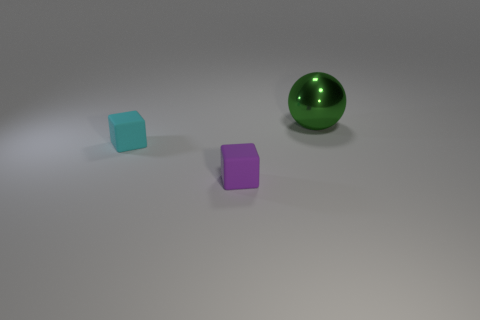How many shiny things have the same color as the metallic sphere?
Offer a terse response. 0. There is a purple rubber thing that is the same size as the cyan thing; what is its shape?
Keep it short and to the point. Cube. Is there a green object that has the same size as the metal sphere?
Offer a terse response. No. What is the material of the cyan cube that is the same size as the purple rubber object?
Your response must be concise. Rubber. What size is the rubber block right of the matte cube behind the purple rubber block?
Your answer should be very brief. Small. Do the rubber thing that is right of the cyan cube and the green sphere have the same size?
Provide a succinct answer. No. Is the number of green balls to the left of the green sphere greater than the number of cyan blocks behind the tiny cyan matte object?
Your answer should be very brief. No. The thing that is both in front of the big green metal sphere and behind the tiny purple object has what shape?
Offer a very short reply. Cube. What shape is the tiny matte thing that is right of the cyan matte object?
Offer a very short reply. Cube. There is a cube in front of the thing that is to the left of the small block on the right side of the cyan matte object; what size is it?
Offer a very short reply. Small. 